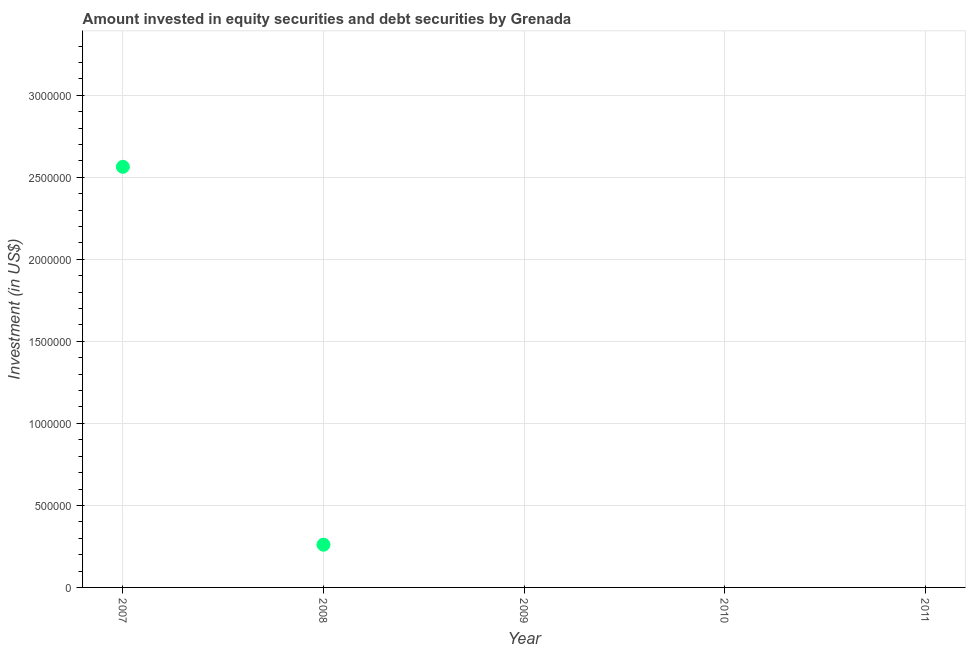What is the portfolio investment in 2010?
Your response must be concise. 0. Across all years, what is the maximum portfolio investment?
Provide a short and direct response. 2.56e+06. Across all years, what is the minimum portfolio investment?
Give a very brief answer. 0. What is the sum of the portfolio investment?
Give a very brief answer. 2.82e+06. What is the difference between the portfolio investment in 2007 and 2008?
Provide a short and direct response. 2.30e+06. What is the average portfolio investment per year?
Provide a succinct answer. 5.65e+05. What is the median portfolio investment?
Your response must be concise. 0. In how many years, is the portfolio investment greater than 3000000 US$?
Your response must be concise. 0. What is the ratio of the portfolio investment in 2007 to that in 2008?
Keep it short and to the point. 9.84. Is the portfolio investment in 2007 less than that in 2008?
Offer a terse response. No. What is the difference between the highest and the lowest portfolio investment?
Your answer should be very brief. 2.56e+06. In how many years, is the portfolio investment greater than the average portfolio investment taken over all years?
Keep it short and to the point. 1. Does the portfolio investment monotonically increase over the years?
Ensure brevity in your answer.  No. How many years are there in the graph?
Provide a short and direct response. 5. Are the values on the major ticks of Y-axis written in scientific E-notation?
Offer a terse response. No. Does the graph contain any zero values?
Provide a succinct answer. Yes. What is the title of the graph?
Make the answer very short. Amount invested in equity securities and debt securities by Grenada. What is the label or title of the X-axis?
Your answer should be very brief. Year. What is the label or title of the Y-axis?
Ensure brevity in your answer.  Investment (in US$). What is the Investment (in US$) in 2007?
Make the answer very short. 2.56e+06. What is the Investment (in US$) in 2008?
Offer a very short reply. 2.61e+05. What is the Investment (in US$) in 2009?
Keep it short and to the point. 0. What is the Investment (in US$) in 2010?
Your answer should be compact. 0. What is the Investment (in US$) in 2011?
Make the answer very short. 0. What is the difference between the Investment (in US$) in 2007 and 2008?
Make the answer very short. 2.30e+06. What is the ratio of the Investment (in US$) in 2007 to that in 2008?
Ensure brevity in your answer.  9.84. 